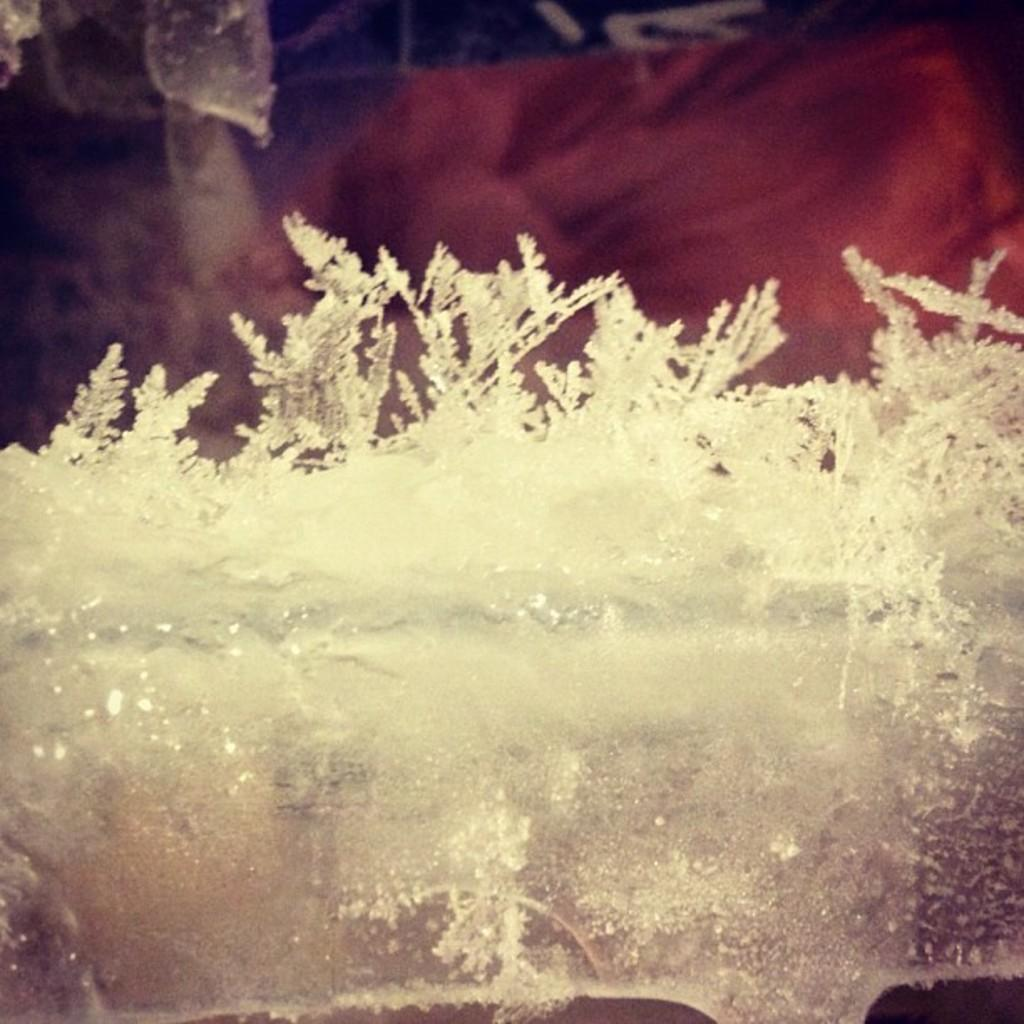What is the main subject in the center of the image? There is ice in the center of the image. How does the father transport the ice in the image? There is no father or transportation method present in the image; it only features ice. 